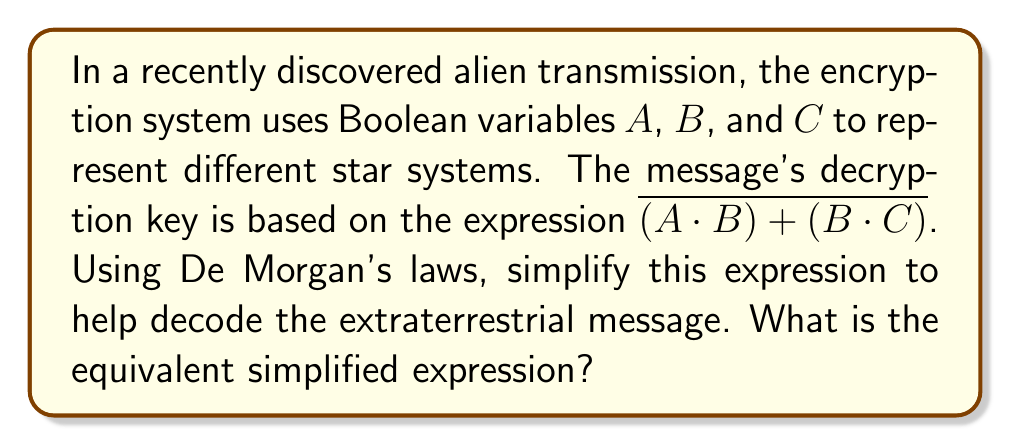Give your solution to this math problem. Let's apply De Morgan's laws to simplify the expression $\overline{(A \cdot B) + (B \cdot C)}$ step by step:

1. De Morgan's law states that the negation of a disjunction is the conjunction of the negations. In other words:
   $$\overline{X + Y} = \overline{X} \cdot \overline{Y}$$

2. Applying this to our expression:
   $$\overline{(A \cdot B) + (B \cdot C)} = \overline{(A \cdot B)} \cdot \overline{(B \cdot C)}$$

3. Now we can apply De Morgan's law again to each term. The law states that the negation of a conjunction is the disjunction of the negations:
   $$\overline{X \cdot Y} = \overline{X} + \overline{Y}$$

4. Applying this to both terms:
   $$\overline{(A \cdot B)} \cdot \overline{(B \cdot C)} = (\overline{A} + \overline{B}) \cdot (\overline{B} + \overline{C})$$

5. Now we have the simplified expression in its final form:
   $$(\overline{A} + \overline{B}) \cdot (\overline{B} + \overline{C})$$

This simplified expression is equivalent to the original and can be used to decode the alien message more efficiently.
Answer: $(\overline{A} + \overline{B}) \cdot (\overline{B} + \overline{C})$ 